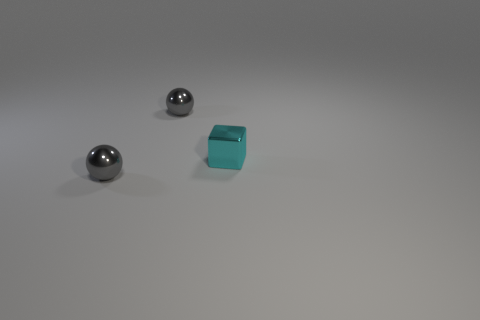Are any green shiny spheres visible?
Provide a short and direct response. No. There is a shiny thing that is behind the tiny metallic block; what number of small cyan objects are left of it?
Offer a very short reply. 0. There is a shiny thing behind the tiny cyan object; what shape is it?
Offer a terse response. Sphere. What is the material of the tiny gray thing on the right side of the tiny gray shiny ball that is in front of the tiny object behind the small cyan cube?
Offer a very short reply. Metal. What number of other things are the same size as the metal block?
Offer a terse response. 2. The block has what color?
Make the answer very short. Cyan. What color is the small metallic object left of the gray metallic thing behind the shiny cube?
Provide a succinct answer. Gray. There is a metal cube; does it have the same color as the thing in front of the tiny cyan block?
Your response must be concise. No. There is a small metal sphere that is in front of the tiny gray metallic ball that is behind the tiny cyan thing; how many tiny gray balls are to the right of it?
Provide a short and direct response. 1. Are there any tiny gray metallic balls left of the tiny cyan shiny cube?
Give a very brief answer. Yes. 